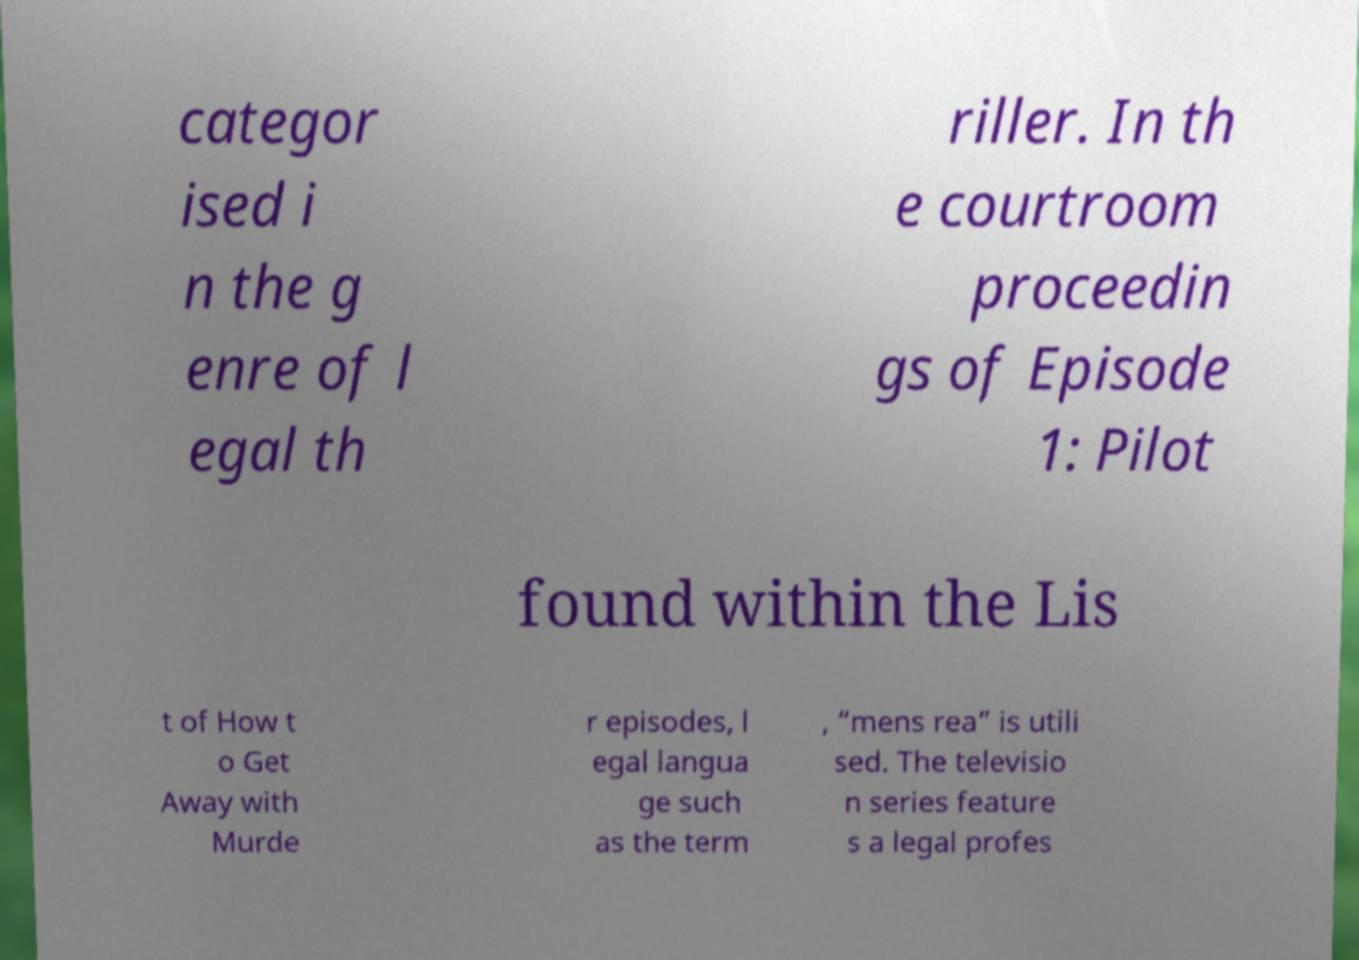Can you read and provide the text displayed in the image?This photo seems to have some interesting text. Can you extract and type it out for me? categor ised i n the g enre of l egal th riller. In th e courtroom proceedin gs of Episode 1: Pilot found within the Lis t of How t o Get Away with Murde r episodes, l egal langua ge such as the term , “mens rea” is utili sed. The televisio n series feature s a legal profes 